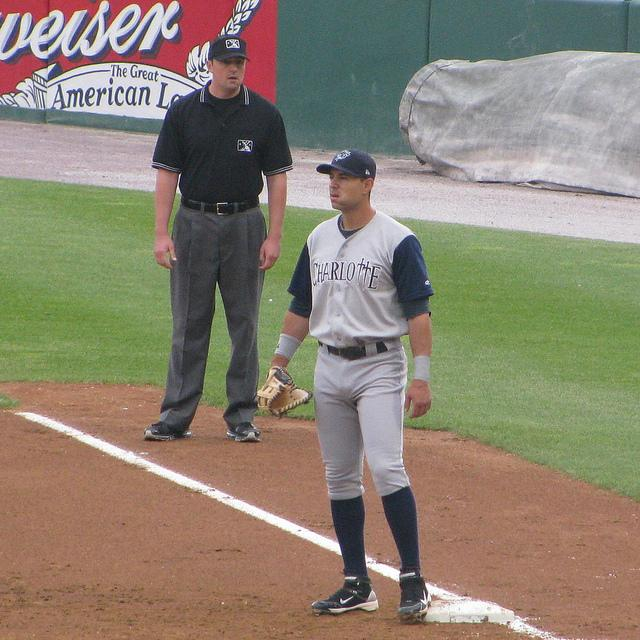What is the person dress in black's job? umpire 